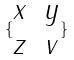<formula> <loc_0><loc_0><loc_500><loc_500>\{ \begin{matrix} x & y \\ z & v \end{matrix} \}</formula> 